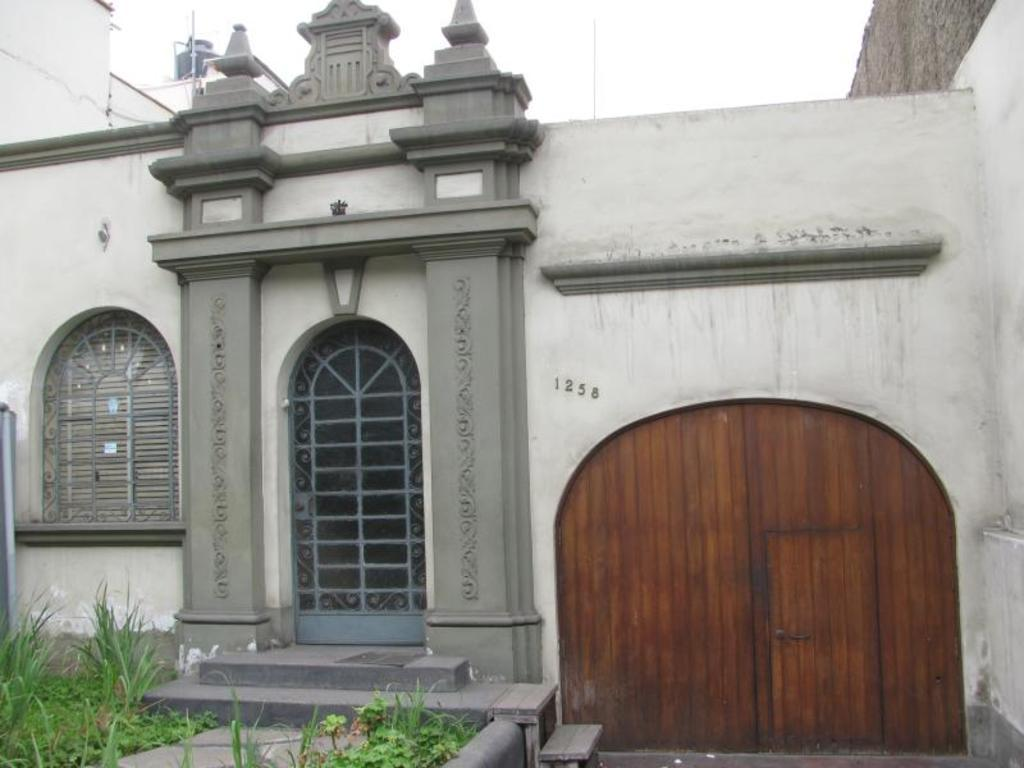What type of structure is present in the image? There is a building in the image. What are the possible points of entry or exit in the image? There are doors in the image. Is there any opening that allows light and air into the building? Yes, there is a window in the image. What type of vegetation can be seen in the image? There is grass and plants in the image. What can be seen in the background of the image? The sky is visible in the background of the image. What type of sugar is being used as bait in the image? There is no sugar or bait present in the image. 